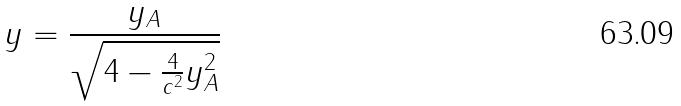Convert formula to latex. <formula><loc_0><loc_0><loc_500><loc_500>y = \frac { y _ { A } } { \sqrt { 4 - \frac { 4 } { c ^ { 2 } } y _ { A } ^ { 2 } } }</formula> 